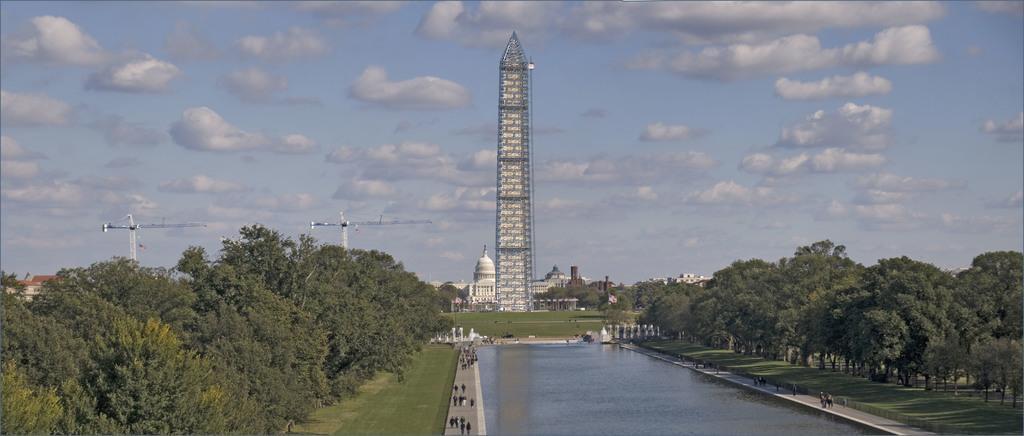Could you give a brief overview of what you see in this image? In this image we can see a group of persons are walking on the ground, here is the water, here are the trees, here is the grass, here is the tower, at above the sky is cloudy. 